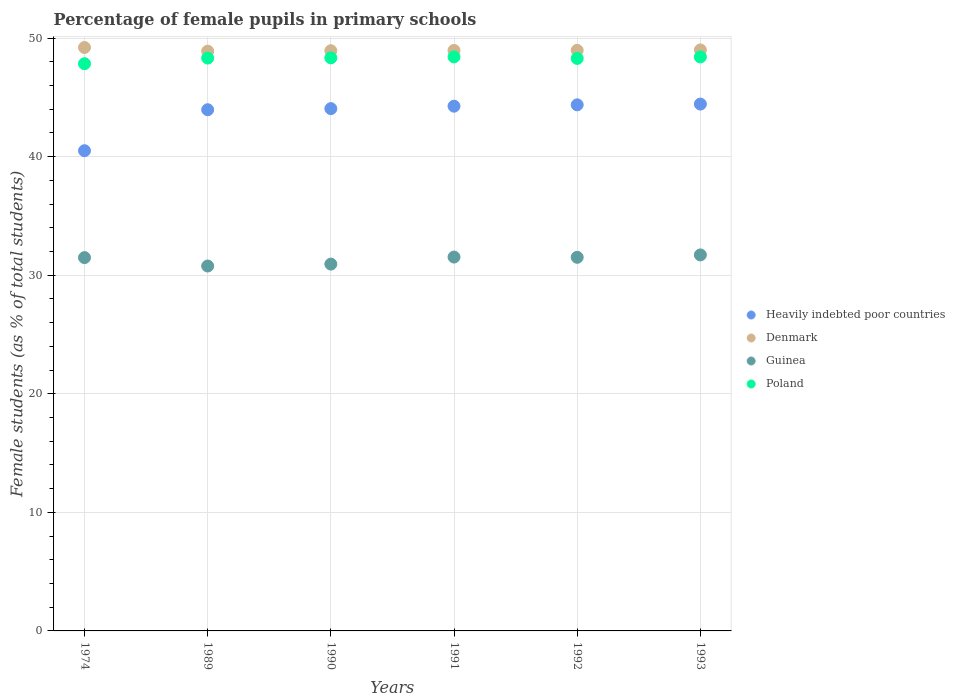How many different coloured dotlines are there?
Provide a succinct answer. 4. Is the number of dotlines equal to the number of legend labels?
Your answer should be very brief. Yes. What is the percentage of female pupils in primary schools in Heavily indebted poor countries in 1992?
Keep it short and to the point. 44.37. Across all years, what is the maximum percentage of female pupils in primary schools in Poland?
Provide a short and direct response. 48.41. Across all years, what is the minimum percentage of female pupils in primary schools in Poland?
Make the answer very short. 47.84. In which year was the percentage of female pupils in primary schools in Heavily indebted poor countries maximum?
Offer a terse response. 1993. In which year was the percentage of female pupils in primary schools in Poland minimum?
Keep it short and to the point. 1974. What is the total percentage of female pupils in primary schools in Heavily indebted poor countries in the graph?
Give a very brief answer. 261.56. What is the difference between the percentage of female pupils in primary schools in Poland in 1991 and that in 1993?
Your answer should be compact. 0. What is the difference between the percentage of female pupils in primary schools in Poland in 1990 and the percentage of female pupils in primary schools in Heavily indebted poor countries in 1974?
Your response must be concise. 7.83. What is the average percentage of female pupils in primary schools in Poland per year?
Give a very brief answer. 48.26. In the year 1989, what is the difference between the percentage of female pupils in primary schools in Guinea and percentage of female pupils in primary schools in Poland?
Make the answer very short. -17.54. In how many years, is the percentage of female pupils in primary schools in Guinea greater than 42 %?
Your answer should be very brief. 0. What is the ratio of the percentage of female pupils in primary schools in Heavily indebted poor countries in 1989 to that in 1990?
Keep it short and to the point. 1. What is the difference between the highest and the second highest percentage of female pupils in primary schools in Guinea?
Give a very brief answer. 0.18. What is the difference between the highest and the lowest percentage of female pupils in primary schools in Denmark?
Keep it short and to the point. 0.31. Is it the case that in every year, the sum of the percentage of female pupils in primary schools in Guinea and percentage of female pupils in primary schools in Denmark  is greater than the percentage of female pupils in primary schools in Heavily indebted poor countries?
Keep it short and to the point. Yes. Does the percentage of female pupils in primary schools in Heavily indebted poor countries monotonically increase over the years?
Provide a succinct answer. Yes. How many years are there in the graph?
Your answer should be compact. 6. What is the difference between two consecutive major ticks on the Y-axis?
Provide a short and direct response. 10. Does the graph contain grids?
Keep it short and to the point. Yes. Where does the legend appear in the graph?
Offer a terse response. Center right. What is the title of the graph?
Make the answer very short. Percentage of female pupils in primary schools. Does "Least developed countries" appear as one of the legend labels in the graph?
Give a very brief answer. No. What is the label or title of the Y-axis?
Keep it short and to the point. Female students (as % of total students). What is the Female students (as % of total students) of Heavily indebted poor countries in 1974?
Provide a succinct answer. 40.5. What is the Female students (as % of total students) of Denmark in 1974?
Make the answer very short. 49.2. What is the Female students (as % of total students) in Guinea in 1974?
Your response must be concise. 31.48. What is the Female students (as % of total students) of Poland in 1974?
Keep it short and to the point. 47.84. What is the Female students (as % of total students) in Heavily indebted poor countries in 1989?
Provide a succinct answer. 43.96. What is the Female students (as % of total students) of Denmark in 1989?
Make the answer very short. 48.89. What is the Female students (as % of total students) of Guinea in 1989?
Keep it short and to the point. 30.78. What is the Female students (as % of total students) of Poland in 1989?
Give a very brief answer. 48.31. What is the Female students (as % of total students) in Heavily indebted poor countries in 1990?
Offer a terse response. 44.05. What is the Female students (as % of total students) of Denmark in 1990?
Offer a very short reply. 48.93. What is the Female students (as % of total students) of Guinea in 1990?
Offer a very short reply. 30.94. What is the Female students (as % of total students) of Poland in 1990?
Make the answer very short. 48.33. What is the Female students (as % of total students) of Heavily indebted poor countries in 1991?
Give a very brief answer. 44.26. What is the Female students (as % of total students) in Denmark in 1991?
Make the answer very short. 48.96. What is the Female students (as % of total students) in Guinea in 1991?
Provide a short and direct response. 31.53. What is the Female students (as % of total students) of Poland in 1991?
Provide a succinct answer. 48.41. What is the Female students (as % of total students) of Heavily indebted poor countries in 1992?
Provide a succinct answer. 44.37. What is the Female students (as % of total students) of Denmark in 1992?
Make the answer very short. 48.96. What is the Female students (as % of total students) of Guinea in 1992?
Ensure brevity in your answer.  31.51. What is the Female students (as % of total students) of Poland in 1992?
Your answer should be very brief. 48.28. What is the Female students (as % of total students) of Heavily indebted poor countries in 1993?
Keep it short and to the point. 44.43. What is the Female students (as % of total students) of Denmark in 1993?
Ensure brevity in your answer.  49. What is the Female students (as % of total students) in Guinea in 1993?
Your response must be concise. 31.71. What is the Female students (as % of total students) in Poland in 1993?
Give a very brief answer. 48.41. Across all years, what is the maximum Female students (as % of total students) of Heavily indebted poor countries?
Your answer should be very brief. 44.43. Across all years, what is the maximum Female students (as % of total students) of Denmark?
Offer a very short reply. 49.2. Across all years, what is the maximum Female students (as % of total students) of Guinea?
Your answer should be very brief. 31.71. Across all years, what is the maximum Female students (as % of total students) of Poland?
Give a very brief answer. 48.41. Across all years, what is the minimum Female students (as % of total students) in Heavily indebted poor countries?
Make the answer very short. 40.5. Across all years, what is the minimum Female students (as % of total students) of Denmark?
Keep it short and to the point. 48.89. Across all years, what is the minimum Female students (as % of total students) in Guinea?
Ensure brevity in your answer.  30.78. Across all years, what is the minimum Female students (as % of total students) of Poland?
Give a very brief answer. 47.84. What is the total Female students (as % of total students) in Heavily indebted poor countries in the graph?
Your answer should be very brief. 261.56. What is the total Female students (as % of total students) in Denmark in the graph?
Provide a succinct answer. 293.95. What is the total Female students (as % of total students) of Guinea in the graph?
Provide a succinct answer. 187.95. What is the total Female students (as % of total students) of Poland in the graph?
Ensure brevity in your answer.  289.58. What is the difference between the Female students (as % of total students) in Heavily indebted poor countries in 1974 and that in 1989?
Provide a succinct answer. -3.46. What is the difference between the Female students (as % of total students) of Denmark in 1974 and that in 1989?
Keep it short and to the point. 0.31. What is the difference between the Female students (as % of total students) in Guinea in 1974 and that in 1989?
Your answer should be very brief. 0.71. What is the difference between the Female students (as % of total students) in Poland in 1974 and that in 1989?
Offer a very short reply. -0.48. What is the difference between the Female students (as % of total students) in Heavily indebted poor countries in 1974 and that in 1990?
Provide a short and direct response. -3.55. What is the difference between the Female students (as % of total students) in Denmark in 1974 and that in 1990?
Offer a terse response. 0.27. What is the difference between the Female students (as % of total students) in Guinea in 1974 and that in 1990?
Your response must be concise. 0.55. What is the difference between the Female students (as % of total students) of Poland in 1974 and that in 1990?
Your answer should be very brief. -0.5. What is the difference between the Female students (as % of total students) of Heavily indebted poor countries in 1974 and that in 1991?
Your answer should be very brief. -3.76. What is the difference between the Female students (as % of total students) in Denmark in 1974 and that in 1991?
Provide a succinct answer. 0.25. What is the difference between the Female students (as % of total students) in Guinea in 1974 and that in 1991?
Ensure brevity in your answer.  -0.05. What is the difference between the Female students (as % of total students) in Poland in 1974 and that in 1991?
Ensure brevity in your answer.  -0.58. What is the difference between the Female students (as % of total students) of Heavily indebted poor countries in 1974 and that in 1992?
Give a very brief answer. -3.87. What is the difference between the Female students (as % of total students) of Denmark in 1974 and that in 1992?
Provide a succinct answer. 0.24. What is the difference between the Female students (as % of total students) in Guinea in 1974 and that in 1992?
Offer a terse response. -0.03. What is the difference between the Female students (as % of total students) in Poland in 1974 and that in 1992?
Your answer should be very brief. -0.45. What is the difference between the Female students (as % of total students) of Heavily indebted poor countries in 1974 and that in 1993?
Give a very brief answer. -3.93. What is the difference between the Female students (as % of total students) in Denmark in 1974 and that in 1993?
Make the answer very short. 0.2. What is the difference between the Female students (as % of total students) in Guinea in 1974 and that in 1993?
Provide a short and direct response. -0.23. What is the difference between the Female students (as % of total students) of Poland in 1974 and that in 1993?
Your answer should be very brief. -0.57. What is the difference between the Female students (as % of total students) in Heavily indebted poor countries in 1989 and that in 1990?
Your answer should be very brief. -0.09. What is the difference between the Female students (as % of total students) in Denmark in 1989 and that in 1990?
Make the answer very short. -0.04. What is the difference between the Female students (as % of total students) in Guinea in 1989 and that in 1990?
Provide a short and direct response. -0.16. What is the difference between the Female students (as % of total students) in Poland in 1989 and that in 1990?
Provide a succinct answer. -0.02. What is the difference between the Female students (as % of total students) of Denmark in 1989 and that in 1991?
Offer a terse response. -0.06. What is the difference between the Female students (as % of total students) in Guinea in 1989 and that in 1991?
Your answer should be very brief. -0.76. What is the difference between the Female students (as % of total students) in Poland in 1989 and that in 1991?
Ensure brevity in your answer.  -0.1. What is the difference between the Female students (as % of total students) of Heavily indebted poor countries in 1989 and that in 1992?
Your answer should be compact. -0.41. What is the difference between the Female students (as % of total students) of Denmark in 1989 and that in 1992?
Provide a short and direct response. -0.07. What is the difference between the Female students (as % of total students) in Guinea in 1989 and that in 1992?
Provide a short and direct response. -0.73. What is the difference between the Female students (as % of total students) of Poland in 1989 and that in 1992?
Offer a very short reply. 0.03. What is the difference between the Female students (as % of total students) of Heavily indebted poor countries in 1989 and that in 1993?
Your answer should be compact. -0.48. What is the difference between the Female students (as % of total students) of Denmark in 1989 and that in 1993?
Offer a very short reply. -0.11. What is the difference between the Female students (as % of total students) in Guinea in 1989 and that in 1993?
Offer a terse response. -0.94. What is the difference between the Female students (as % of total students) in Poland in 1989 and that in 1993?
Give a very brief answer. -0.1. What is the difference between the Female students (as % of total students) in Heavily indebted poor countries in 1990 and that in 1991?
Your response must be concise. -0.21. What is the difference between the Female students (as % of total students) in Denmark in 1990 and that in 1991?
Offer a terse response. -0.02. What is the difference between the Female students (as % of total students) of Guinea in 1990 and that in 1991?
Offer a terse response. -0.59. What is the difference between the Female students (as % of total students) in Poland in 1990 and that in 1991?
Keep it short and to the point. -0.08. What is the difference between the Female students (as % of total students) of Heavily indebted poor countries in 1990 and that in 1992?
Your answer should be compact. -0.32. What is the difference between the Female students (as % of total students) in Denmark in 1990 and that in 1992?
Provide a succinct answer. -0.03. What is the difference between the Female students (as % of total students) of Guinea in 1990 and that in 1992?
Your response must be concise. -0.57. What is the difference between the Female students (as % of total students) in Poland in 1990 and that in 1992?
Offer a very short reply. 0.05. What is the difference between the Female students (as % of total students) in Heavily indebted poor countries in 1990 and that in 1993?
Offer a terse response. -0.38. What is the difference between the Female students (as % of total students) of Denmark in 1990 and that in 1993?
Give a very brief answer. -0.07. What is the difference between the Female students (as % of total students) of Guinea in 1990 and that in 1993?
Keep it short and to the point. -0.77. What is the difference between the Female students (as % of total students) of Poland in 1990 and that in 1993?
Your answer should be very brief. -0.08. What is the difference between the Female students (as % of total students) of Heavily indebted poor countries in 1991 and that in 1992?
Keep it short and to the point. -0.11. What is the difference between the Female students (as % of total students) of Denmark in 1991 and that in 1992?
Offer a very short reply. -0.01. What is the difference between the Female students (as % of total students) of Guinea in 1991 and that in 1992?
Make the answer very short. 0.02. What is the difference between the Female students (as % of total students) in Poland in 1991 and that in 1992?
Offer a terse response. 0.13. What is the difference between the Female students (as % of total students) of Heavily indebted poor countries in 1991 and that in 1993?
Your answer should be very brief. -0.18. What is the difference between the Female students (as % of total students) in Denmark in 1991 and that in 1993?
Your response must be concise. -0.04. What is the difference between the Female students (as % of total students) in Guinea in 1991 and that in 1993?
Offer a terse response. -0.18. What is the difference between the Female students (as % of total students) of Poland in 1991 and that in 1993?
Offer a very short reply. 0. What is the difference between the Female students (as % of total students) of Heavily indebted poor countries in 1992 and that in 1993?
Keep it short and to the point. -0.06. What is the difference between the Female students (as % of total students) in Denmark in 1992 and that in 1993?
Keep it short and to the point. -0.04. What is the difference between the Female students (as % of total students) in Guinea in 1992 and that in 1993?
Keep it short and to the point. -0.2. What is the difference between the Female students (as % of total students) of Poland in 1992 and that in 1993?
Offer a terse response. -0.13. What is the difference between the Female students (as % of total students) of Heavily indebted poor countries in 1974 and the Female students (as % of total students) of Denmark in 1989?
Offer a terse response. -8.39. What is the difference between the Female students (as % of total students) of Heavily indebted poor countries in 1974 and the Female students (as % of total students) of Guinea in 1989?
Your answer should be very brief. 9.72. What is the difference between the Female students (as % of total students) of Heavily indebted poor countries in 1974 and the Female students (as % of total students) of Poland in 1989?
Provide a succinct answer. -7.81. What is the difference between the Female students (as % of total students) of Denmark in 1974 and the Female students (as % of total students) of Guinea in 1989?
Ensure brevity in your answer.  18.43. What is the difference between the Female students (as % of total students) of Denmark in 1974 and the Female students (as % of total students) of Poland in 1989?
Offer a terse response. 0.89. What is the difference between the Female students (as % of total students) of Guinea in 1974 and the Female students (as % of total students) of Poland in 1989?
Your answer should be very brief. -16.83. What is the difference between the Female students (as % of total students) in Heavily indebted poor countries in 1974 and the Female students (as % of total students) in Denmark in 1990?
Ensure brevity in your answer.  -8.43. What is the difference between the Female students (as % of total students) of Heavily indebted poor countries in 1974 and the Female students (as % of total students) of Guinea in 1990?
Make the answer very short. 9.56. What is the difference between the Female students (as % of total students) of Heavily indebted poor countries in 1974 and the Female students (as % of total students) of Poland in 1990?
Keep it short and to the point. -7.83. What is the difference between the Female students (as % of total students) in Denmark in 1974 and the Female students (as % of total students) in Guinea in 1990?
Your answer should be compact. 18.27. What is the difference between the Female students (as % of total students) in Denmark in 1974 and the Female students (as % of total students) in Poland in 1990?
Offer a very short reply. 0.87. What is the difference between the Female students (as % of total students) of Guinea in 1974 and the Female students (as % of total students) of Poland in 1990?
Give a very brief answer. -16.85. What is the difference between the Female students (as % of total students) in Heavily indebted poor countries in 1974 and the Female students (as % of total students) in Denmark in 1991?
Provide a succinct answer. -8.46. What is the difference between the Female students (as % of total students) of Heavily indebted poor countries in 1974 and the Female students (as % of total students) of Guinea in 1991?
Your answer should be very brief. 8.97. What is the difference between the Female students (as % of total students) of Heavily indebted poor countries in 1974 and the Female students (as % of total students) of Poland in 1991?
Provide a short and direct response. -7.91. What is the difference between the Female students (as % of total students) in Denmark in 1974 and the Female students (as % of total students) in Guinea in 1991?
Offer a very short reply. 17.67. What is the difference between the Female students (as % of total students) of Denmark in 1974 and the Female students (as % of total students) of Poland in 1991?
Give a very brief answer. 0.79. What is the difference between the Female students (as % of total students) in Guinea in 1974 and the Female students (as % of total students) in Poland in 1991?
Give a very brief answer. -16.93. What is the difference between the Female students (as % of total students) of Heavily indebted poor countries in 1974 and the Female students (as % of total students) of Denmark in 1992?
Ensure brevity in your answer.  -8.46. What is the difference between the Female students (as % of total students) of Heavily indebted poor countries in 1974 and the Female students (as % of total students) of Guinea in 1992?
Your answer should be compact. 8.99. What is the difference between the Female students (as % of total students) in Heavily indebted poor countries in 1974 and the Female students (as % of total students) in Poland in 1992?
Offer a terse response. -7.78. What is the difference between the Female students (as % of total students) in Denmark in 1974 and the Female students (as % of total students) in Guinea in 1992?
Make the answer very short. 17.69. What is the difference between the Female students (as % of total students) of Denmark in 1974 and the Female students (as % of total students) of Poland in 1992?
Make the answer very short. 0.92. What is the difference between the Female students (as % of total students) in Guinea in 1974 and the Female students (as % of total students) in Poland in 1992?
Your response must be concise. -16.8. What is the difference between the Female students (as % of total students) of Heavily indebted poor countries in 1974 and the Female students (as % of total students) of Denmark in 1993?
Keep it short and to the point. -8.5. What is the difference between the Female students (as % of total students) of Heavily indebted poor countries in 1974 and the Female students (as % of total students) of Guinea in 1993?
Ensure brevity in your answer.  8.79. What is the difference between the Female students (as % of total students) in Heavily indebted poor countries in 1974 and the Female students (as % of total students) in Poland in 1993?
Provide a short and direct response. -7.91. What is the difference between the Female students (as % of total students) of Denmark in 1974 and the Female students (as % of total students) of Guinea in 1993?
Offer a terse response. 17.49. What is the difference between the Female students (as % of total students) in Denmark in 1974 and the Female students (as % of total students) in Poland in 1993?
Your answer should be very brief. 0.79. What is the difference between the Female students (as % of total students) in Guinea in 1974 and the Female students (as % of total students) in Poland in 1993?
Make the answer very short. -16.93. What is the difference between the Female students (as % of total students) of Heavily indebted poor countries in 1989 and the Female students (as % of total students) of Denmark in 1990?
Ensure brevity in your answer.  -4.98. What is the difference between the Female students (as % of total students) in Heavily indebted poor countries in 1989 and the Female students (as % of total students) in Guinea in 1990?
Ensure brevity in your answer.  13.02. What is the difference between the Female students (as % of total students) of Heavily indebted poor countries in 1989 and the Female students (as % of total students) of Poland in 1990?
Offer a very short reply. -4.38. What is the difference between the Female students (as % of total students) in Denmark in 1989 and the Female students (as % of total students) in Guinea in 1990?
Your answer should be compact. 17.96. What is the difference between the Female students (as % of total students) in Denmark in 1989 and the Female students (as % of total students) in Poland in 1990?
Your answer should be very brief. 0.56. What is the difference between the Female students (as % of total students) of Guinea in 1989 and the Female students (as % of total students) of Poland in 1990?
Provide a short and direct response. -17.56. What is the difference between the Female students (as % of total students) of Heavily indebted poor countries in 1989 and the Female students (as % of total students) of Denmark in 1991?
Make the answer very short. -5. What is the difference between the Female students (as % of total students) of Heavily indebted poor countries in 1989 and the Female students (as % of total students) of Guinea in 1991?
Make the answer very short. 12.42. What is the difference between the Female students (as % of total students) of Heavily indebted poor countries in 1989 and the Female students (as % of total students) of Poland in 1991?
Your answer should be compact. -4.46. What is the difference between the Female students (as % of total students) of Denmark in 1989 and the Female students (as % of total students) of Guinea in 1991?
Your answer should be very brief. 17.36. What is the difference between the Female students (as % of total students) in Denmark in 1989 and the Female students (as % of total students) in Poland in 1991?
Make the answer very short. 0.48. What is the difference between the Female students (as % of total students) in Guinea in 1989 and the Female students (as % of total students) in Poland in 1991?
Offer a very short reply. -17.64. What is the difference between the Female students (as % of total students) in Heavily indebted poor countries in 1989 and the Female students (as % of total students) in Denmark in 1992?
Your answer should be very brief. -5.01. What is the difference between the Female students (as % of total students) in Heavily indebted poor countries in 1989 and the Female students (as % of total students) in Guinea in 1992?
Offer a very short reply. 12.44. What is the difference between the Female students (as % of total students) in Heavily indebted poor countries in 1989 and the Female students (as % of total students) in Poland in 1992?
Your response must be concise. -4.33. What is the difference between the Female students (as % of total students) in Denmark in 1989 and the Female students (as % of total students) in Guinea in 1992?
Provide a short and direct response. 17.38. What is the difference between the Female students (as % of total students) of Denmark in 1989 and the Female students (as % of total students) of Poland in 1992?
Offer a very short reply. 0.61. What is the difference between the Female students (as % of total students) in Guinea in 1989 and the Female students (as % of total students) in Poland in 1992?
Your response must be concise. -17.51. What is the difference between the Female students (as % of total students) of Heavily indebted poor countries in 1989 and the Female students (as % of total students) of Denmark in 1993?
Make the answer very short. -5.05. What is the difference between the Female students (as % of total students) of Heavily indebted poor countries in 1989 and the Female students (as % of total students) of Guinea in 1993?
Offer a terse response. 12.24. What is the difference between the Female students (as % of total students) in Heavily indebted poor countries in 1989 and the Female students (as % of total students) in Poland in 1993?
Give a very brief answer. -4.45. What is the difference between the Female students (as % of total students) in Denmark in 1989 and the Female students (as % of total students) in Guinea in 1993?
Offer a very short reply. 17.18. What is the difference between the Female students (as % of total students) in Denmark in 1989 and the Female students (as % of total students) in Poland in 1993?
Your answer should be compact. 0.48. What is the difference between the Female students (as % of total students) of Guinea in 1989 and the Female students (as % of total students) of Poland in 1993?
Keep it short and to the point. -17.63. What is the difference between the Female students (as % of total students) in Heavily indebted poor countries in 1990 and the Female students (as % of total students) in Denmark in 1991?
Ensure brevity in your answer.  -4.91. What is the difference between the Female students (as % of total students) in Heavily indebted poor countries in 1990 and the Female students (as % of total students) in Guinea in 1991?
Your answer should be compact. 12.52. What is the difference between the Female students (as % of total students) in Heavily indebted poor countries in 1990 and the Female students (as % of total students) in Poland in 1991?
Your response must be concise. -4.36. What is the difference between the Female students (as % of total students) of Denmark in 1990 and the Female students (as % of total students) of Guinea in 1991?
Ensure brevity in your answer.  17.4. What is the difference between the Female students (as % of total students) in Denmark in 1990 and the Female students (as % of total students) in Poland in 1991?
Offer a terse response. 0.52. What is the difference between the Female students (as % of total students) in Guinea in 1990 and the Female students (as % of total students) in Poland in 1991?
Give a very brief answer. -17.48. What is the difference between the Female students (as % of total students) in Heavily indebted poor countries in 1990 and the Female students (as % of total students) in Denmark in 1992?
Make the answer very short. -4.92. What is the difference between the Female students (as % of total students) in Heavily indebted poor countries in 1990 and the Female students (as % of total students) in Guinea in 1992?
Offer a very short reply. 12.54. What is the difference between the Female students (as % of total students) in Heavily indebted poor countries in 1990 and the Female students (as % of total students) in Poland in 1992?
Give a very brief answer. -4.23. What is the difference between the Female students (as % of total students) in Denmark in 1990 and the Female students (as % of total students) in Guinea in 1992?
Ensure brevity in your answer.  17.42. What is the difference between the Female students (as % of total students) in Denmark in 1990 and the Female students (as % of total students) in Poland in 1992?
Ensure brevity in your answer.  0.65. What is the difference between the Female students (as % of total students) of Guinea in 1990 and the Female students (as % of total students) of Poland in 1992?
Your response must be concise. -17.34. What is the difference between the Female students (as % of total students) in Heavily indebted poor countries in 1990 and the Female students (as % of total students) in Denmark in 1993?
Your answer should be compact. -4.95. What is the difference between the Female students (as % of total students) in Heavily indebted poor countries in 1990 and the Female students (as % of total students) in Guinea in 1993?
Keep it short and to the point. 12.34. What is the difference between the Female students (as % of total students) in Heavily indebted poor countries in 1990 and the Female students (as % of total students) in Poland in 1993?
Provide a succinct answer. -4.36. What is the difference between the Female students (as % of total students) in Denmark in 1990 and the Female students (as % of total students) in Guinea in 1993?
Your answer should be compact. 17.22. What is the difference between the Female students (as % of total students) in Denmark in 1990 and the Female students (as % of total students) in Poland in 1993?
Keep it short and to the point. 0.52. What is the difference between the Female students (as % of total students) of Guinea in 1990 and the Female students (as % of total students) of Poland in 1993?
Give a very brief answer. -17.47. What is the difference between the Female students (as % of total students) in Heavily indebted poor countries in 1991 and the Female students (as % of total students) in Denmark in 1992?
Make the answer very short. -4.71. What is the difference between the Female students (as % of total students) in Heavily indebted poor countries in 1991 and the Female students (as % of total students) in Guinea in 1992?
Your response must be concise. 12.74. What is the difference between the Female students (as % of total students) in Heavily indebted poor countries in 1991 and the Female students (as % of total students) in Poland in 1992?
Provide a succinct answer. -4.03. What is the difference between the Female students (as % of total students) of Denmark in 1991 and the Female students (as % of total students) of Guinea in 1992?
Offer a very short reply. 17.45. What is the difference between the Female students (as % of total students) of Denmark in 1991 and the Female students (as % of total students) of Poland in 1992?
Offer a very short reply. 0.67. What is the difference between the Female students (as % of total students) of Guinea in 1991 and the Female students (as % of total students) of Poland in 1992?
Offer a very short reply. -16.75. What is the difference between the Female students (as % of total students) of Heavily indebted poor countries in 1991 and the Female students (as % of total students) of Denmark in 1993?
Your answer should be very brief. -4.75. What is the difference between the Female students (as % of total students) in Heavily indebted poor countries in 1991 and the Female students (as % of total students) in Guinea in 1993?
Ensure brevity in your answer.  12.54. What is the difference between the Female students (as % of total students) of Heavily indebted poor countries in 1991 and the Female students (as % of total students) of Poland in 1993?
Provide a short and direct response. -4.15. What is the difference between the Female students (as % of total students) in Denmark in 1991 and the Female students (as % of total students) in Guinea in 1993?
Offer a terse response. 17.25. What is the difference between the Female students (as % of total students) of Denmark in 1991 and the Female students (as % of total students) of Poland in 1993?
Offer a terse response. 0.55. What is the difference between the Female students (as % of total students) of Guinea in 1991 and the Female students (as % of total students) of Poland in 1993?
Offer a terse response. -16.88. What is the difference between the Female students (as % of total students) in Heavily indebted poor countries in 1992 and the Female students (as % of total students) in Denmark in 1993?
Offer a very short reply. -4.63. What is the difference between the Female students (as % of total students) of Heavily indebted poor countries in 1992 and the Female students (as % of total students) of Guinea in 1993?
Your response must be concise. 12.66. What is the difference between the Female students (as % of total students) of Heavily indebted poor countries in 1992 and the Female students (as % of total students) of Poland in 1993?
Keep it short and to the point. -4.04. What is the difference between the Female students (as % of total students) in Denmark in 1992 and the Female students (as % of total students) in Guinea in 1993?
Provide a short and direct response. 17.25. What is the difference between the Female students (as % of total students) in Denmark in 1992 and the Female students (as % of total students) in Poland in 1993?
Provide a succinct answer. 0.55. What is the difference between the Female students (as % of total students) of Guinea in 1992 and the Female students (as % of total students) of Poland in 1993?
Ensure brevity in your answer.  -16.9. What is the average Female students (as % of total students) of Heavily indebted poor countries per year?
Keep it short and to the point. 43.59. What is the average Female students (as % of total students) of Denmark per year?
Your answer should be very brief. 48.99. What is the average Female students (as % of total students) in Guinea per year?
Provide a short and direct response. 31.32. What is the average Female students (as % of total students) of Poland per year?
Ensure brevity in your answer.  48.26. In the year 1974, what is the difference between the Female students (as % of total students) in Heavily indebted poor countries and Female students (as % of total students) in Denmark?
Ensure brevity in your answer.  -8.7. In the year 1974, what is the difference between the Female students (as % of total students) of Heavily indebted poor countries and Female students (as % of total students) of Guinea?
Your response must be concise. 9.02. In the year 1974, what is the difference between the Female students (as % of total students) of Heavily indebted poor countries and Female students (as % of total students) of Poland?
Provide a succinct answer. -7.34. In the year 1974, what is the difference between the Female students (as % of total students) in Denmark and Female students (as % of total students) in Guinea?
Ensure brevity in your answer.  17.72. In the year 1974, what is the difference between the Female students (as % of total students) in Denmark and Female students (as % of total students) in Poland?
Provide a succinct answer. 1.37. In the year 1974, what is the difference between the Female students (as % of total students) in Guinea and Female students (as % of total students) in Poland?
Your answer should be very brief. -16.35. In the year 1989, what is the difference between the Female students (as % of total students) of Heavily indebted poor countries and Female students (as % of total students) of Denmark?
Provide a succinct answer. -4.94. In the year 1989, what is the difference between the Female students (as % of total students) in Heavily indebted poor countries and Female students (as % of total students) in Guinea?
Give a very brief answer. 13.18. In the year 1989, what is the difference between the Female students (as % of total students) in Heavily indebted poor countries and Female students (as % of total students) in Poland?
Give a very brief answer. -4.36. In the year 1989, what is the difference between the Female students (as % of total students) in Denmark and Female students (as % of total students) in Guinea?
Provide a succinct answer. 18.12. In the year 1989, what is the difference between the Female students (as % of total students) of Denmark and Female students (as % of total students) of Poland?
Ensure brevity in your answer.  0.58. In the year 1989, what is the difference between the Female students (as % of total students) in Guinea and Female students (as % of total students) in Poland?
Keep it short and to the point. -17.54. In the year 1990, what is the difference between the Female students (as % of total students) of Heavily indebted poor countries and Female students (as % of total students) of Denmark?
Make the answer very short. -4.88. In the year 1990, what is the difference between the Female students (as % of total students) in Heavily indebted poor countries and Female students (as % of total students) in Guinea?
Your answer should be compact. 13.11. In the year 1990, what is the difference between the Female students (as % of total students) of Heavily indebted poor countries and Female students (as % of total students) of Poland?
Keep it short and to the point. -4.28. In the year 1990, what is the difference between the Female students (as % of total students) of Denmark and Female students (as % of total students) of Guinea?
Make the answer very short. 18. In the year 1990, what is the difference between the Female students (as % of total students) of Denmark and Female students (as % of total students) of Poland?
Make the answer very short. 0.6. In the year 1990, what is the difference between the Female students (as % of total students) in Guinea and Female students (as % of total students) in Poland?
Provide a short and direct response. -17.4. In the year 1991, what is the difference between the Female students (as % of total students) in Heavily indebted poor countries and Female students (as % of total students) in Denmark?
Offer a very short reply. -4.7. In the year 1991, what is the difference between the Female students (as % of total students) in Heavily indebted poor countries and Female students (as % of total students) in Guinea?
Give a very brief answer. 12.72. In the year 1991, what is the difference between the Female students (as % of total students) of Heavily indebted poor countries and Female students (as % of total students) of Poland?
Offer a very short reply. -4.16. In the year 1991, what is the difference between the Female students (as % of total students) in Denmark and Female students (as % of total students) in Guinea?
Keep it short and to the point. 17.43. In the year 1991, what is the difference between the Female students (as % of total students) of Denmark and Female students (as % of total students) of Poland?
Ensure brevity in your answer.  0.54. In the year 1991, what is the difference between the Female students (as % of total students) in Guinea and Female students (as % of total students) in Poland?
Ensure brevity in your answer.  -16.88. In the year 1992, what is the difference between the Female students (as % of total students) in Heavily indebted poor countries and Female students (as % of total students) in Denmark?
Ensure brevity in your answer.  -4.6. In the year 1992, what is the difference between the Female students (as % of total students) in Heavily indebted poor countries and Female students (as % of total students) in Guinea?
Provide a succinct answer. 12.86. In the year 1992, what is the difference between the Female students (as % of total students) in Heavily indebted poor countries and Female students (as % of total students) in Poland?
Your answer should be very brief. -3.91. In the year 1992, what is the difference between the Female students (as % of total students) in Denmark and Female students (as % of total students) in Guinea?
Provide a short and direct response. 17.45. In the year 1992, what is the difference between the Female students (as % of total students) of Denmark and Female students (as % of total students) of Poland?
Your answer should be compact. 0.68. In the year 1992, what is the difference between the Female students (as % of total students) of Guinea and Female students (as % of total students) of Poland?
Provide a short and direct response. -16.77. In the year 1993, what is the difference between the Female students (as % of total students) in Heavily indebted poor countries and Female students (as % of total students) in Denmark?
Your response must be concise. -4.57. In the year 1993, what is the difference between the Female students (as % of total students) of Heavily indebted poor countries and Female students (as % of total students) of Guinea?
Give a very brief answer. 12.72. In the year 1993, what is the difference between the Female students (as % of total students) of Heavily indebted poor countries and Female students (as % of total students) of Poland?
Your response must be concise. -3.98. In the year 1993, what is the difference between the Female students (as % of total students) of Denmark and Female students (as % of total students) of Guinea?
Keep it short and to the point. 17.29. In the year 1993, what is the difference between the Female students (as % of total students) of Denmark and Female students (as % of total students) of Poland?
Keep it short and to the point. 0.59. In the year 1993, what is the difference between the Female students (as % of total students) of Guinea and Female students (as % of total students) of Poland?
Your answer should be compact. -16.7. What is the ratio of the Female students (as % of total students) in Heavily indebted poor countries in 1974 to that in 1989?
Offer a terse response. 0.92. What is the ratio of the Female students (as % of total students) in Poland in 1974 to that in 1989?
Offer a very short reply. 0.99. What is the ratio of the Female students (as % of total students) in Heavily indebted poor countries in 1974 to that in 1990?
Provide a succinct answer. 0.92. What is the ratio of the Female students (as % of total students) of Denmark in 1974 to that in 1990?
Provide a short and direct response. 1.01. What is the ratio of the Female students (as % of total students) in Guinea in 1974 to that in 1990?
Ensure brevity in your answer.  1.02. What is the ratio of the Female students (as % of total students) in Poland in 1974 to that in 1990?
Ensure brevity in your answer.  0.99. What is the ratio of the Female students (as % of total students) in Heavily indebted poor countries in 1974 to that in 1991?
Your answer should be compact. 0.92. What is the ratio of the Female students (as % of total students) in Denmark in 1974 to that in 1991?
Provide a succinct answer. 1.01. What is the ratio of the Female students (as % of total students) of Guinea in 1974 to that in 1991?
Your response must be concise. 1. What is the ratio of the Female students (as % of total students) in Heavily indebted poor countries in 1974 to that in 1992?
Give a very brief answer. 0.91. What is the ratio of the Female students (as % of total students) in Guinea in 1974 to that in 1992?
Keep it short and to the point. 1. What is the ratio of the Female students (as % of total students) of Heavily indebted poor countries in 1974 to that in 1993?
Make the answer very short. 0.91. What is the ratio of the Female students (as % of total students) of Denmark in 1974 to that in 1993?
Offer a terse response. 1. What is the ratio of the Female students (as % of total students) in Guinea in 1974 to that in 1993?
Your response must be concise. 0.99. What is the ratio of the Female students (as % of total students) in Poland in 1974 to that in 1993?
Provide a succinct answer. 0.99. What is the ratio of the Female students (as % of total students) of Guinea in 1989 to that in 1990?
Offer a very short reply. 0.99. What is the ratio of the Female students (as % of total students) of Poland in 1989 to that in 1990?
Offer a terse response. 1. What is the ratio of the Female students (as % of total students) in Denmark in 1989 to that in 1991?
Offer a terse response. 1. What is the ratio of the Female students (as % of total students) of Poland in 1989 to that in 1991?
Provide a succinct answer. 1. What is the ratio of the Female students (as % of total students) in Guinea in 1989 to that in 1992?
Your response must be concise. 0.98. What is the ratio of the Female students (as % of total students) in Poland in 1989 to that in 1992?
Offer a terse response. 1. What is the ratio of the Female students (as % of total students) of Heavily indebted poor countries in 1989 to that in 1993?
Your answer should be very brief. 0.99. What is the ratio of the Female students (as % of total students) in Denmark in 1989 to that in 1993?
Make the answer very short. 1. What is the ratio of the Female students (as % of total students) in Guinea in 1989 to that in 1993?
Keep it short and to the point. 0.97. What is the ratio of the Female students (as % of total students) in Heavily indebted poor countries in 1990 to that in 1991?
Provide a short and direct response. 1. What is the ratio of the Female students (as % of total students) in Denmark in 1990 to that in 1991?
Give a very brief answer. 1. What is the ratio of the Female students (as % of total students) of Guinea in 1990 to that in 1991?
Offer a terse response. 0.98. What is the ratio of the Female students (as % of total students) in Poland in 1990 to that in 1991?
Give a very brief answer. 1. What is the ratio of the Female students (as % of total students) in Guinea in 1990 to that in 1992?
Provide a succinct answer. 0.98. What is the ratio of the Female students (as % of total students) of Denmark in 1990 to that in 1993?
Offer a terse response. 1. What is the ratio of the Female students (as % of total students) in Guinea in 1990 to that in 1993?
Your answer should be very brief. 0.98. What is the ratio of the Female students (as % of total students) of Heavily indebted poor countries in 1991 to that in 1992?
Provide a succinct answer. 1. What is the ratio of the Female students (as % of total students) of Heavily indebted poor countries in 1991 to that in 1993?
Make the answer very short. 1. What is the ratio of the Female students (as % of total students) of Guinea in 1991 to that in 1993?
Keep it short and to the point. 0.99. What is the ratio of the Female students (as % of total students) in Poland in 1991 to that in 1993?
Ensure brevity in your answer.  1. What is the ratio of the Female students (as % of total students) in Denmark in 1992 to that in 1993?
Keep it short and to the point. 1. What is the difference between the highest and the second highest Female students (as % of total students) of Heavily indebted poor countries?
Make the answer very short. 0.06. What is the difference between the highest and the second highest Female students (as % of total students) of Denmark?
Provide a short and direct response. 0.2. What is the difference between the highest and the second highest Female students (as % of total students) in Guinea?
Provide a short and direct response. 0.18. What is the difference between the highest and the second highest Female students (as % of total students) of Poland?
Your answer should be compact. 0. What is the difference between the highest and the lowest Female students (as % of total students) of Heavily indebted poor countries?
Provide a short and direct response. 3.93. What is the difference between the highest and the lowest Female students (as % of total students) in Denmark?
Give a very brief answer. 0.31. What is the difference between the highest and the lowest Female students (as % of total students) of Guinea?
Offer a terse response. 0.94. What is the difference between the highest and the lowest Female students (as % of total students) in Poland?
Make the answer very short. 0.58. 